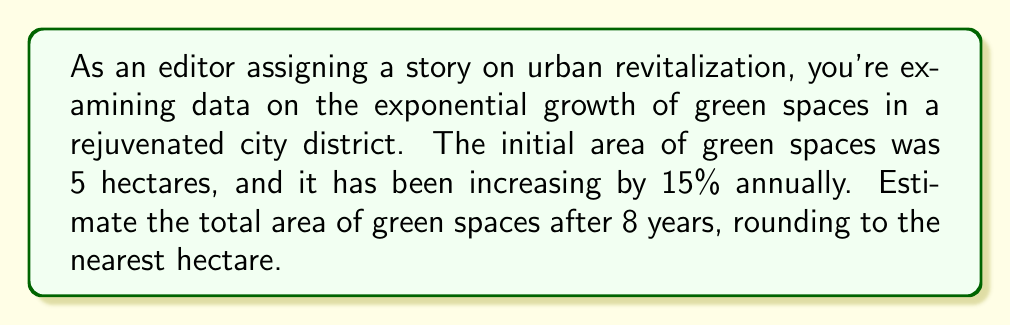Can you answer this question? To solve this problem, we'll use the exponential growth formula:

$$A = A_0 \cdot (1 + r)^t$$

Where:
$A$ = Final amount
$A_0$ = Initial amount
$r$ = Growth rate (as a decimal)
$t$ = Time period

Given:
$A_0 = 5$ hectares
$r = 15\% = 0.15$
$t = 8$ years

Let's substitute these values into the formula:

$$A = 5 \cdot (1 + 0.15)^8$$

Now, let's calculate step-by-step:

1) First, calculate $(1 + 0.15)$:
   $1 + 0.15 = 1.15$

2) Now, we need to calculate $1.15^8$:
   $1.15^8 \approx 3.0590$

3) Finally, multiply by the initial amount:
   $5 \cdot 3.0590 \approx 15.2950$

4) Rounding to the nearest hectare:
   $15.2950 \approx 15$ hectares
Answer: The estimated total area of green spaces after 8 years is 15 hectares. 